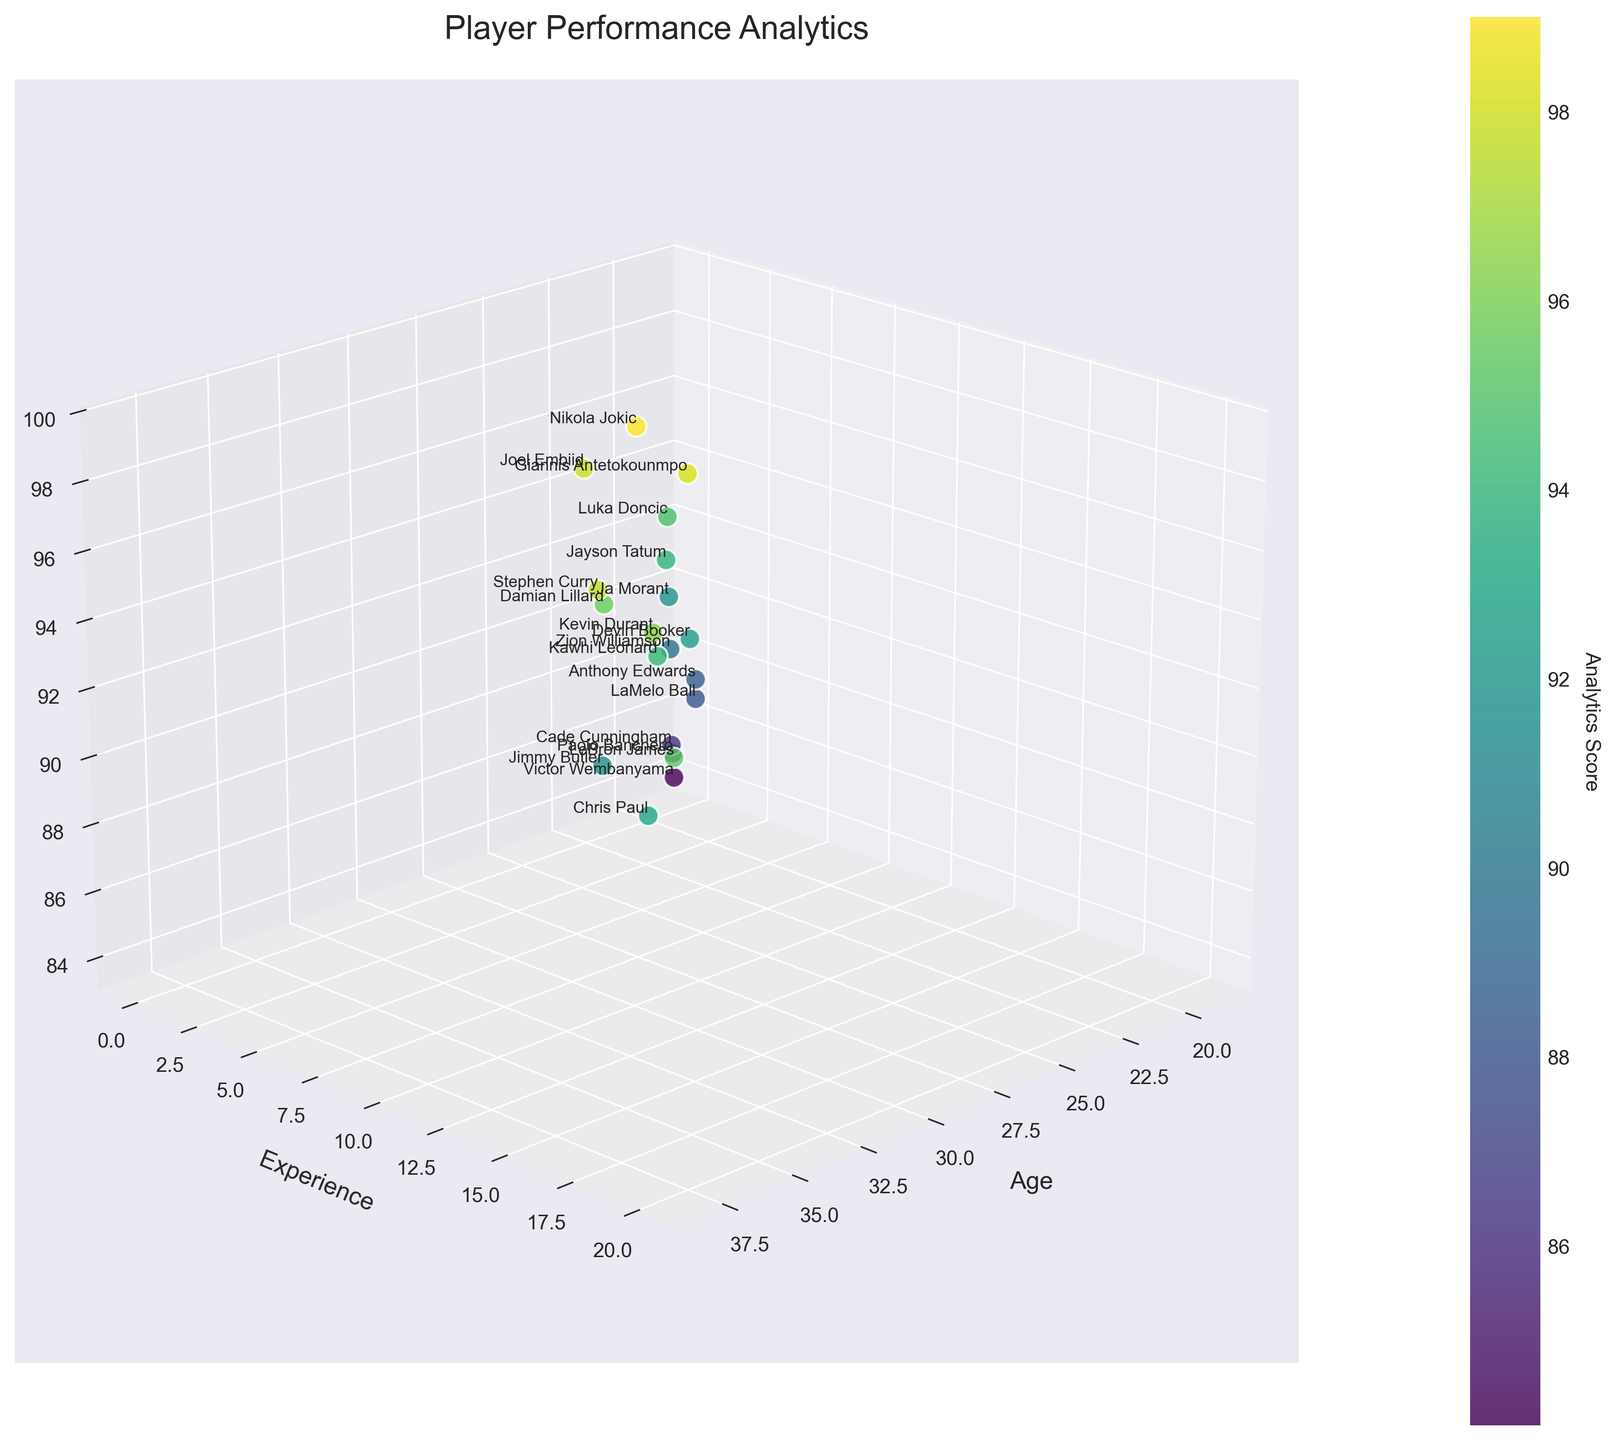what is the title of the plot? The title is displayed at the top of the figure and is the most noticeable text in bold.
Answer: Player Performance Analytics How many data points are represented in the plot? Count the number of markers in the scatter plot.
Answer: 20 What is the highest analytics score in the plot, and which player has it? Look at the color gradient and locate the marker at the highest point on the vertical axis. The player name is written next to that marker.
Answer: Nikola Jokic with 99.0 Which player has the least experience but has a higher analytics score than Anthony Edwards? Identify Anthony Edwards by his experience value. Then look for players with less experience and a higher score.
Answer: Paolo Banchero How does the analytics score trend with increasing experience among players aged 28? Isolate the points where age is 28 and compare their analytics scores based on their experience.
Answer: Varies, but Nikola Jokic has a higher score than Giannis Antetokounmpo Which player aged 35 has the highest analytics score? Locate the points at age 35 and compare their analytics scores.
Answer: Stephen Curry Compare the analytics scores of Jimmy Butler and Kawhi Leonard. Who has a higher score? Locate both players using their names in the plot and compare their scores directly.
Answer: Kawhi Leonard Does age or experience have a more noticeable impact on analytics score based on visual clustering in the plot? Observe the spread of points and their color variations along the age and experience axes to determine which factor shows a clearer trend.
Answer: Experience seems to have more impact Describe the relationship between analytics scores and player age for players with fewer than 5 years of experience. Identify points with less than 5 years of experience and observe any pattern in their analytics scores according to age.
Answer: Scores generally decrease with decreasing age 